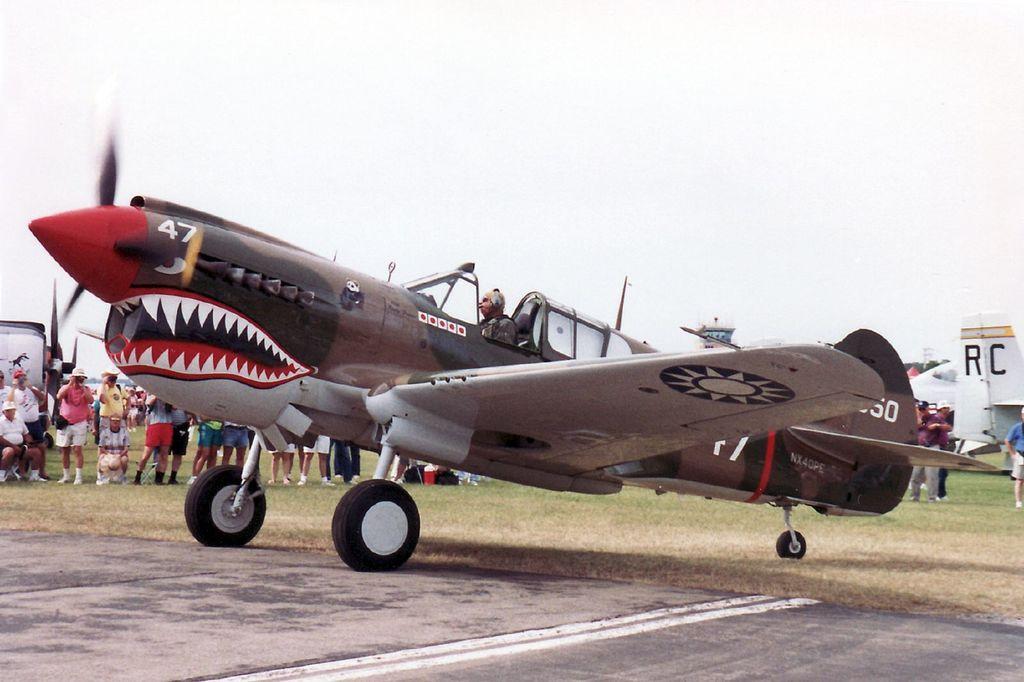What two numbers are behind the propeller on the airplane?
Give a very brief answer. 47. 